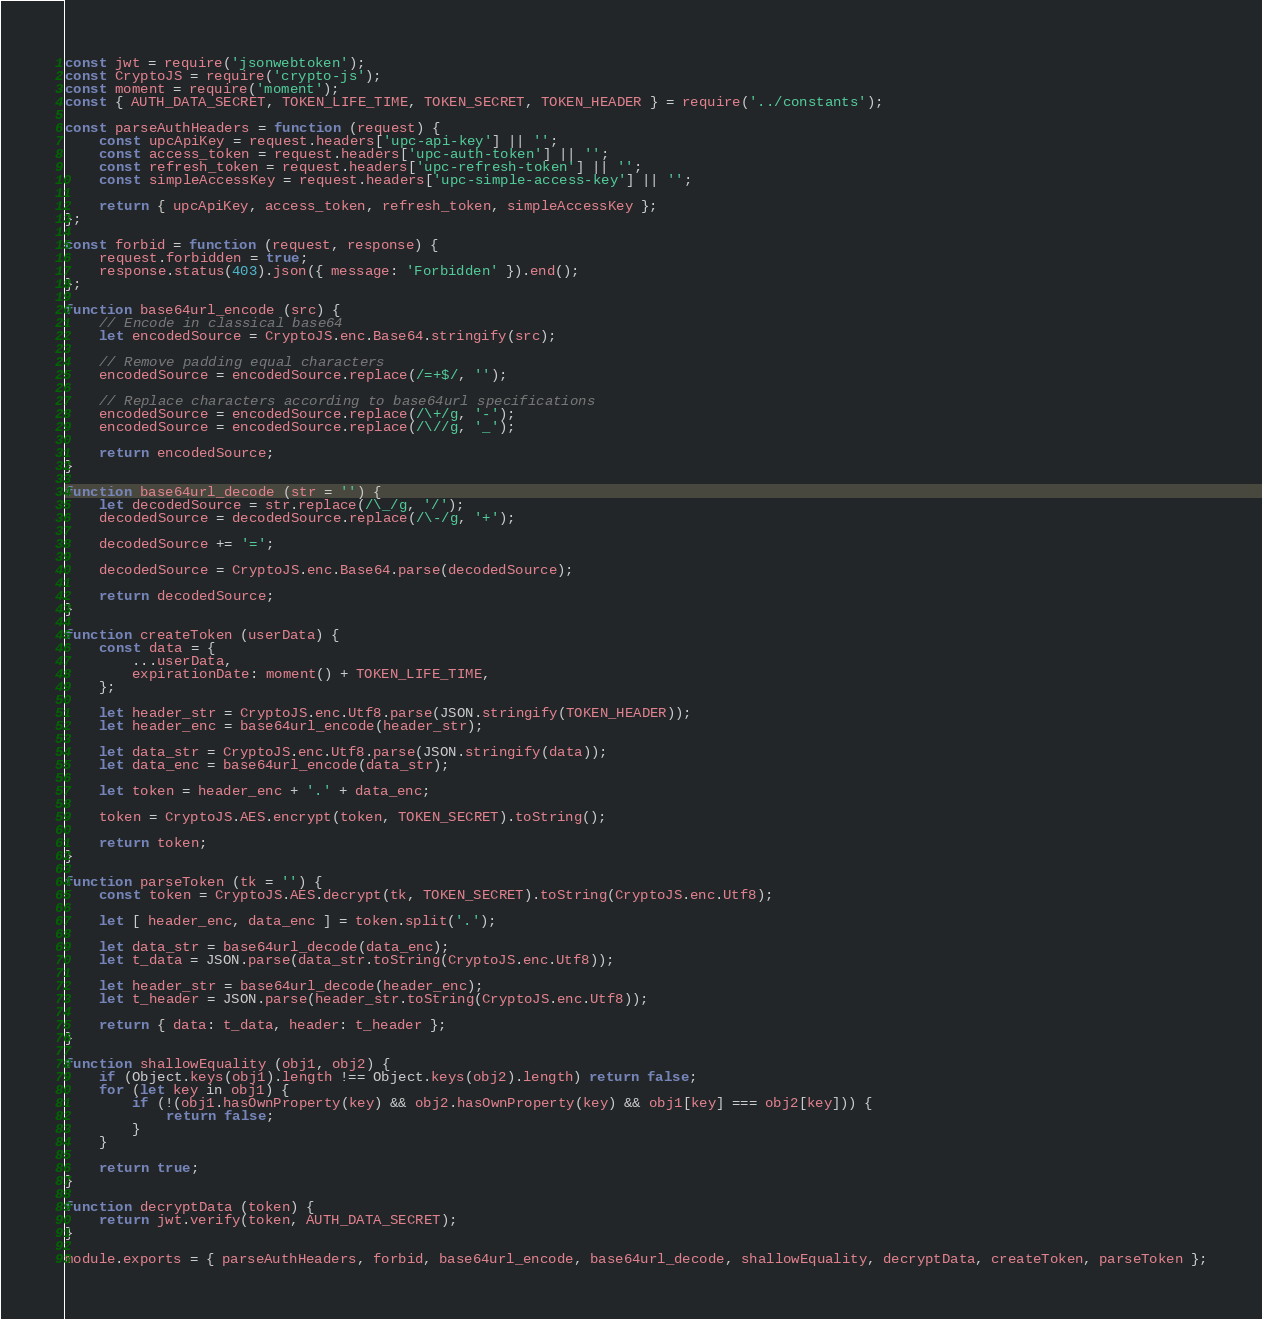Convert code to text. <code><loc_0><loc_0><loc_500><loc_500><_JavaScript_>const jwt = require('jsonwebtoken');
const CryptoJS = require('crypto-js');
const moment = require('moment');
const { AUTH_DATA_SECRET, TOKEN_LIFE_TIME, TOKEN_SECRET, TOKEN_HEADER } = require('../constants');

const parseAuthHeaders = function (request) {
    const upcApiKey = request.headers['upc-api-key'] || '';
    const access_token = request.headers['upc-auth-token'] || '';
    const refresh_token = request.headers['upc-refresh-token'] || '';
    const simpleAccessKey = request.headers['upc-simple-access-key'] || '';

    return { upcApiKey, access_token, refresh_token, simpleAccessKey };
};

const forbid = function (request, response) {
    request.forbidden = true;
    response.status(403).json({ message: 'Forbidden' }).end();
};

function base64url_encode (src) {
    // Encode in classical base64
    let encodedSource = CryptoJS.enc.Base64.stringify(src);

    // Remove padding equal characters
    encodedSource = encodedSource.replace(/=+$/, '');

    // Replace characters according to base64url specifications
    encodedSource = encodedSource.replace(/\+/g, '-');
    encodedSource = encodedSource.replace(/\//g, '_');

    return encodedSource;
}

function base64url_decode (str = '') {
    let decodedSource = str.replace(/\_/g, '/');
    decodedSource = decodedSource.replace(/\-/g, '+');

    decodedSource += '=';

    decodedSource = CryptoJS.enc.Base64.parse(decodedSource);

    return decodedSource;
}

function createToken (userData) {
    const data = {
        ...userData,
        expirationDate: moment() + TOKEN_LIFE_TIME,
    };

    let header_str = CryptoJS.enc.Utf8.parse(JSON.stringify(TOKEN_HEADER));
    let header_enc = base64url_encode(header_str);

    let data_str = CryptoJS.enc.Utf8.parse(JSON.stringify(data));
    let data_enc = base64url_encode(data_str);

    let token = header_enc + '.' + data_enc;

    token = CryptoJS.AES.encrypt(token, TOKEN_SECRET).toString();

    return token;
}

function parseToken (tk = '') {
    const token = CryptoJS.AES.decrypt(tk, TOKEN_SECRET).toString(CryptoJS.enc.Utf8);

    let [ header_enc, data_enc ] = token.split('.');

    let data_str = base64url_decode(data_enc);
    let t_data = JSON.parse(data_str.toString(CryptoJS.enc.Utf8));

    let header_str = base64url_decode(header_enc);
    let t_header = JSON.parse(header_str.toString(CryptoJS.enc.Utf8));

    return { data: t_data, header: t_header };
}

function shallowEquality (obj1, obj2) {
    if (Object.keys(obj1).length !== Object.keys(obj2).length) return false;
    for (let key in obj1) {
        if (!(obj1.hasOwnProperty(key) && obj2.hasOwnProperty(key) && obj1[key] === obj2[key])) {
            return false;
        }
    }

    return true;
}

function decryptData (token) {
    return jwt.verify(token, AUTH_DATA_SECRET);
}

module.exports = { parseAuthHeaders, forbid, base64url_encode, base64url_decode, shallowEquality, decryptData, createToken, parseToken };</code> 